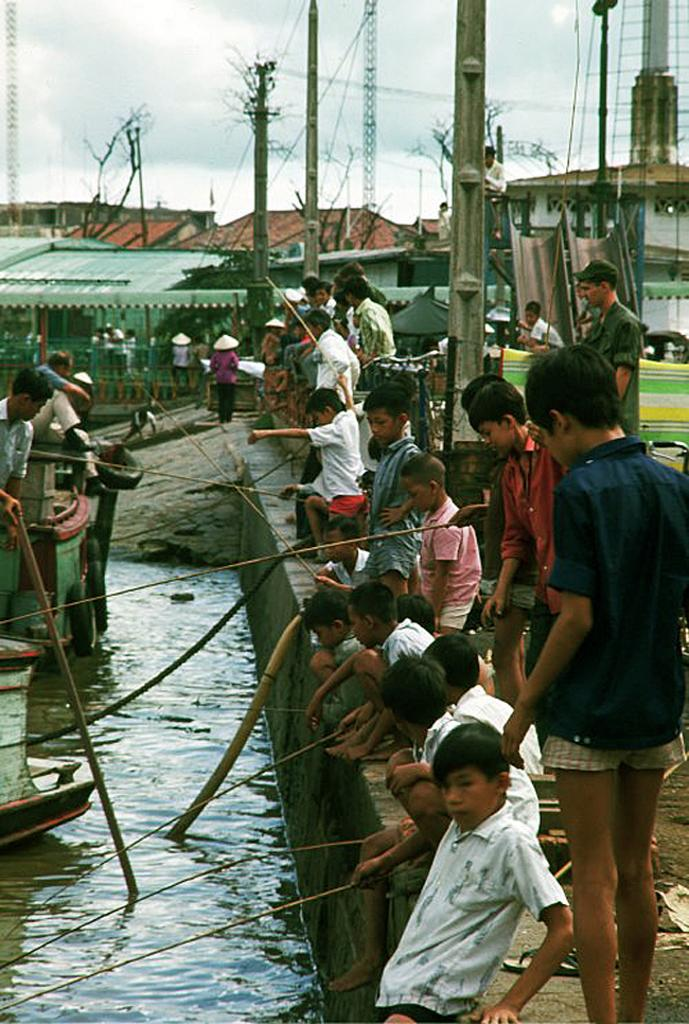What type of structures can be seen in the image? There are houses in the image. What are the people in the image doing? There are people sitting beside the water in the image. What can be seen floating in the water? There are ships in the water in the image. What type of news can be heard coming from the houses in the image? There is no indication in the image that any news is being broadcast or discussed, so it cannot be determined from the picture. 